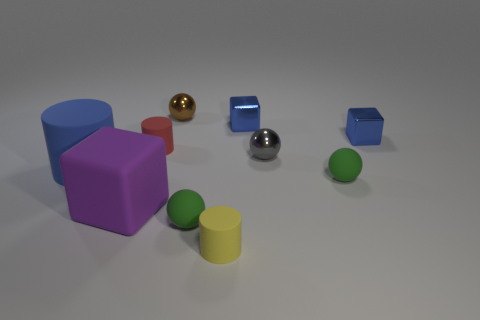There is a tiny red object; are there any cubes in front of it?
Give a very brief answer. Yes. There is a rubber cube; is it the same size as the matte thing left of the purple thing?
Your answer should be very brief. Yes. How many other objects are the same material as the gray sphere?
Your response must be concise. 3. The blue thing that is on the left side of the gray ball and to the right of the tiny red object has what shape?
Give a very brief answer. Cube. There is a brown object behind the yellow object; is its size the same as the cylinder that is in front of the large purple block?
Ensure brevity in your answer.  Yes. There is a large purple thing that is the same material as the red thing; what is its shape?
Give a very brief answer. Cube. There is a small matte cylinder in front of the small rubber object that is behind the cylinder to the left of the red object; what is its color?
Give a very brief answer. Yellow. Are there fewer yellow cylinders to the right of the large purple rubber cube than tiny things that are left of the tiny gray object?
Your response must be concise. Yes. Does the blue matte thing have the same shape as the red object?
Your response must be concise. Yes. What number of green matte spheres are the same size as the blue rubber cylinder?
Your response must be concise. 0. 